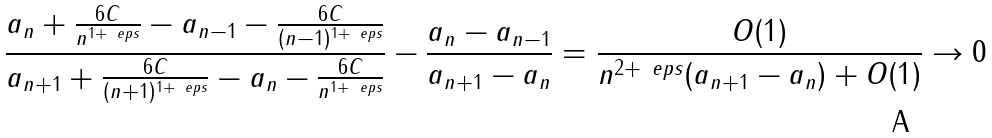Convert formula to latex. <formula><loc_0><loc_0><loc_500><loc_500>\frac { a _ { n } + \frac { 6 C } { n ^ { 1 + \ e p s } } - a _ { n - 1 } - \frac { 6 C } { ( n - 1 ) ^ { 1 + \ e p s } } } { a _ { n + 1 } + \frac { 6 C } { ( n + 1 ) ^ { 1 + \ e p s } } - a _ { n } - \frac { 6 C } { n ^ { 1 + \ e p s } } } - \frac { a _ { n } - a _ { n - 1 } } { a _ { n + 1 } - a _ { n } } = \frac { O ( 1 ) } { n ^ { 2 + \ e p s } ( a _ { n + 1 } - a _ { n } ) + O ( 1 ) } \to 0</formula> 